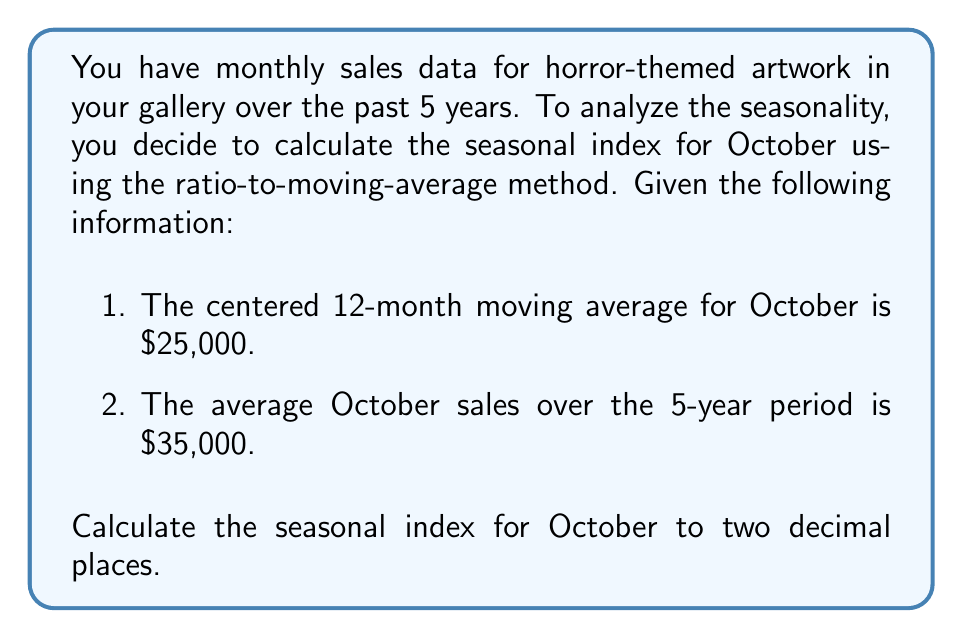Can you solve this math problem? To calculate the seasonal index using the ratio-to-moving-average method, we follow these steps:

1. The seasonal index is calculated by dividing the actual value for a given period by the centered moving average for that same period.

2. In this case, we're given the average October sales over 5 years, which we'll use as our actual value, and the centered 12-month moving average for October.

3. The formula for the seasonal index is:

   $$\text{Seasonal Index} = \frac{\text{Actual Value}}{\text{Centered Moving Average}} \times 100$$

4. Let's plug in our values:

   $$\text{Seasonal Index} = \frac{35,000}{25,000} \times 100$$

5. Simplify:

   $$\text{Seasonal Index} = 1.4 \times 100 = 140$$

6. This means that October sales are typically 40% higher than the average month.

7. Rounding to two decimal places, we get 140.00.

This seasonal index of 140.00 indicates a strong positive seasonality for horror-themed art sales in October, which aligns with expectations given the proximity to Halloween.
Answer: 140.00 